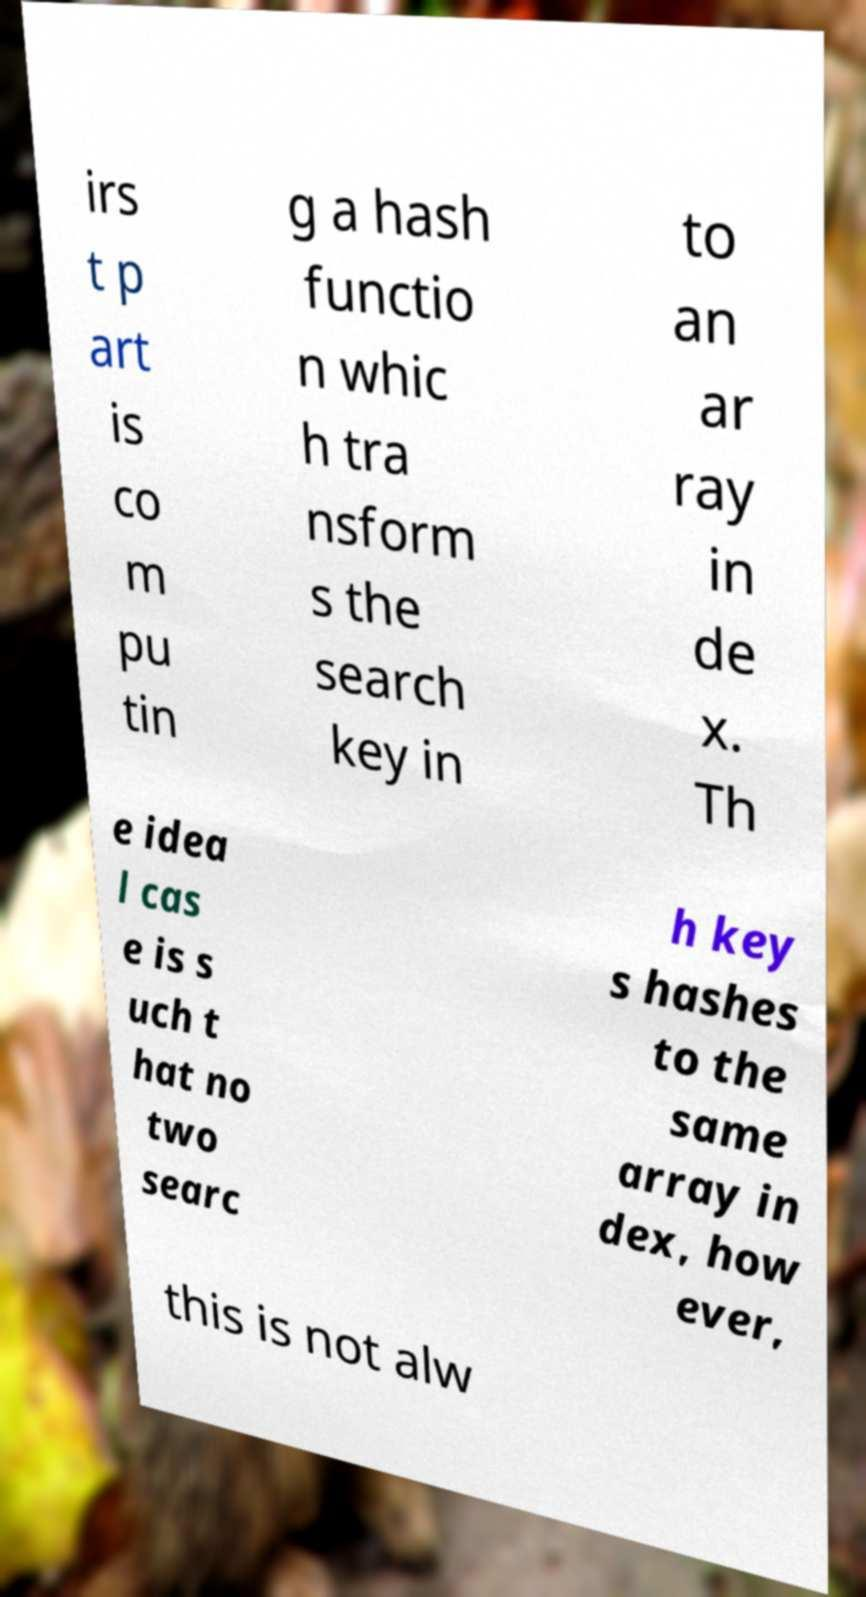For documentation purposes, I need the text within this image transcribed. Could you provide that? irs t p art is co m pu tin g a hash functio n whic h tra nsform s the search key in to an ar ray in de x. Th e idea l cas e is s uch t hat no two searc h key s hashes to the same array in dex, how ever, this is not alw 